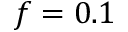<formula> <loc_0><loc_0><loc_500><loc_500>f = 0 . 1</formula> 